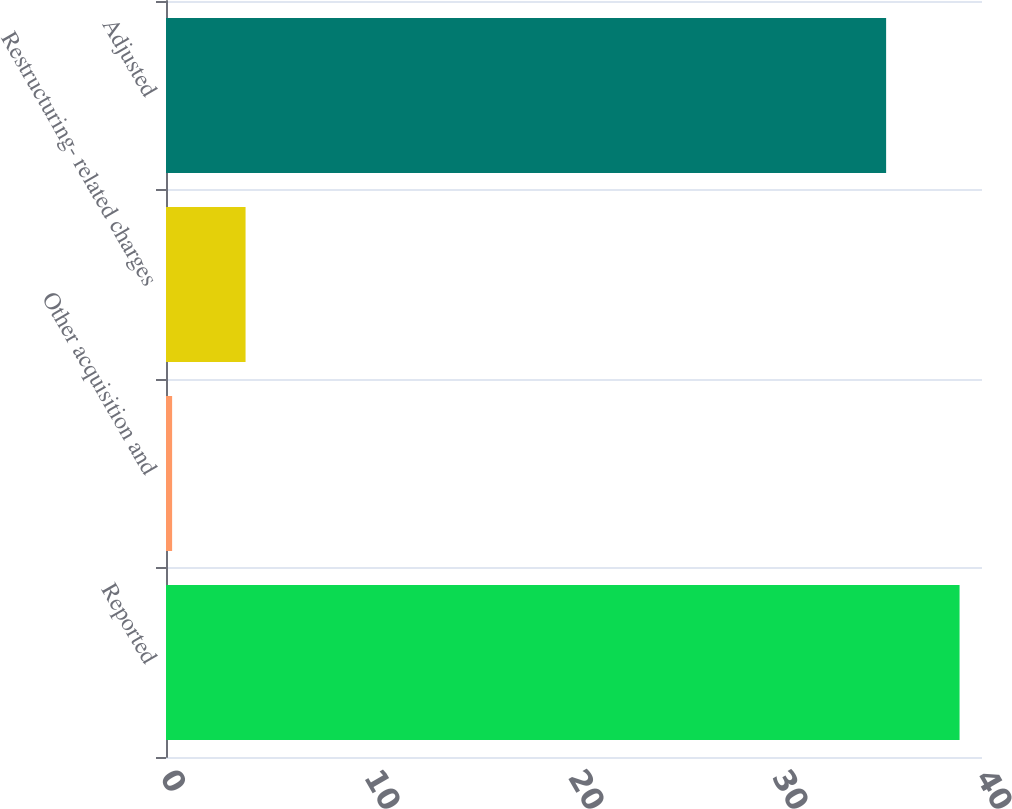Convert chart to OTSL. <chart><loc_0><loc_0><loc_500><loc_500><bar_chart><fcel>Reported<fcel>Other acquisition and<fcel>Restructuring- related charges<fcel>Adjusted<nl><fcel>38.9<fcel>0.3<fcel>3.9<fcel>35.3<nl></chart> 